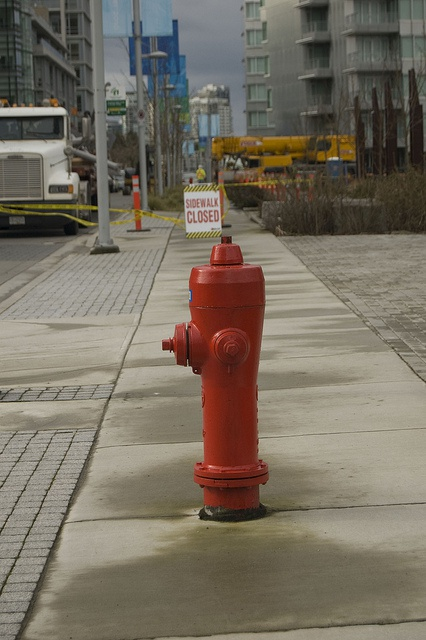Describe the objects in this image and their specific colors. I can see fire hydrant in black, maroon, and brown tones, truck in black, gray, darkgray, and olive tones, and truck in black and olive tones in this image. 